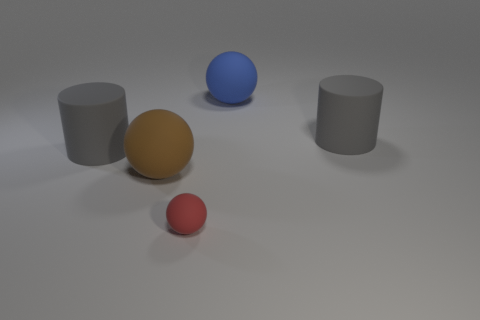The brown matte sphere has what size?
Your answer should be compact. Large. How many tiny metal cylinders are there?
Keep it short and to the point. 0. What number of things are large cyan metal objects or big brown matte objects?
Your response must be concise. 1. How many small objects are in front of the gray cylinder that is left of the blue rubber thing right of the brown matte sphere?
Your answer should be very brief. 1. There is a matte object that is on the left side of the large brown rubber sphere; is it the same color as the matte cylinder that is to the right of the big brown rubber sphere?
Your answer should be very brief. Yes. Are there more brown things behind the red rubber sphere than red rubber spheres to the left of the brown rubber ball?
Provide a short and direct response. Yes. What material is the blue thing?
Give a very brief answer. Rubber. What is the shape of the big gray matte object in front of the cylinder to the right of the large rubber ball that is on the right side of the large brown sphere?
Keep it short and to the point. Cylinder. How many other objects are the same material as the brown object?
Your answer should be very brief. 4. Are the cylinder that is on the right side of the brown thing and the gray cylinder left of the small red matte ball made of the same material?
Offer a terse response. Yes. 